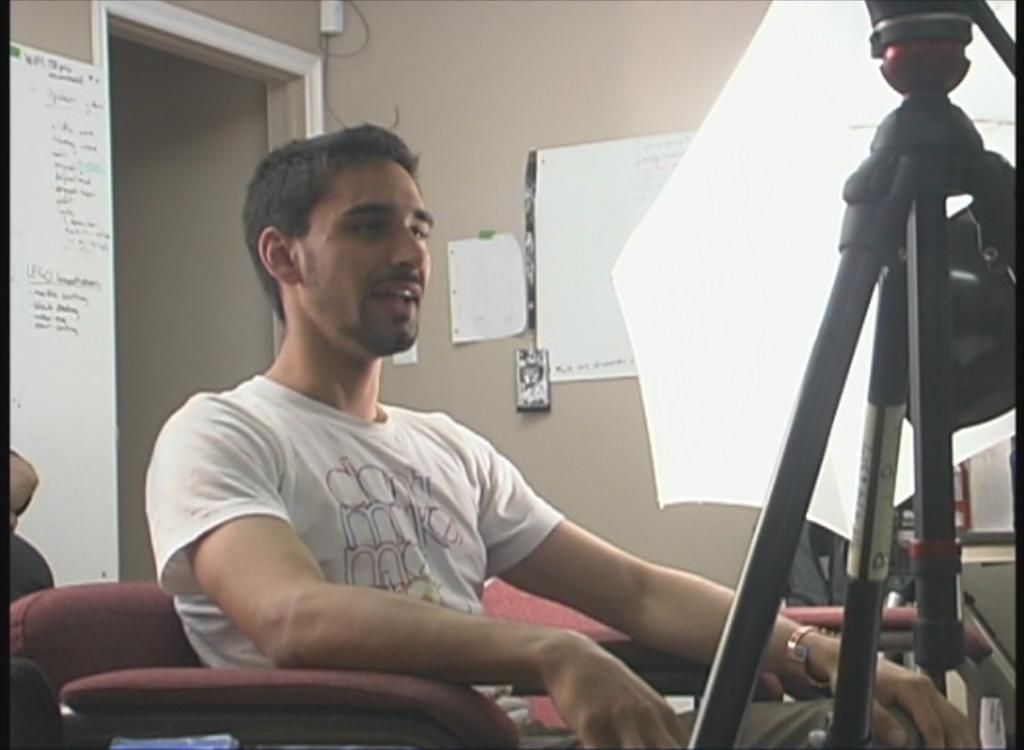Please provide a concise description of this image. This image consists of a man sitting in a sofa. In front of him, there is a tripod stand. In the background, there is a wall on which many charts are pasted. 